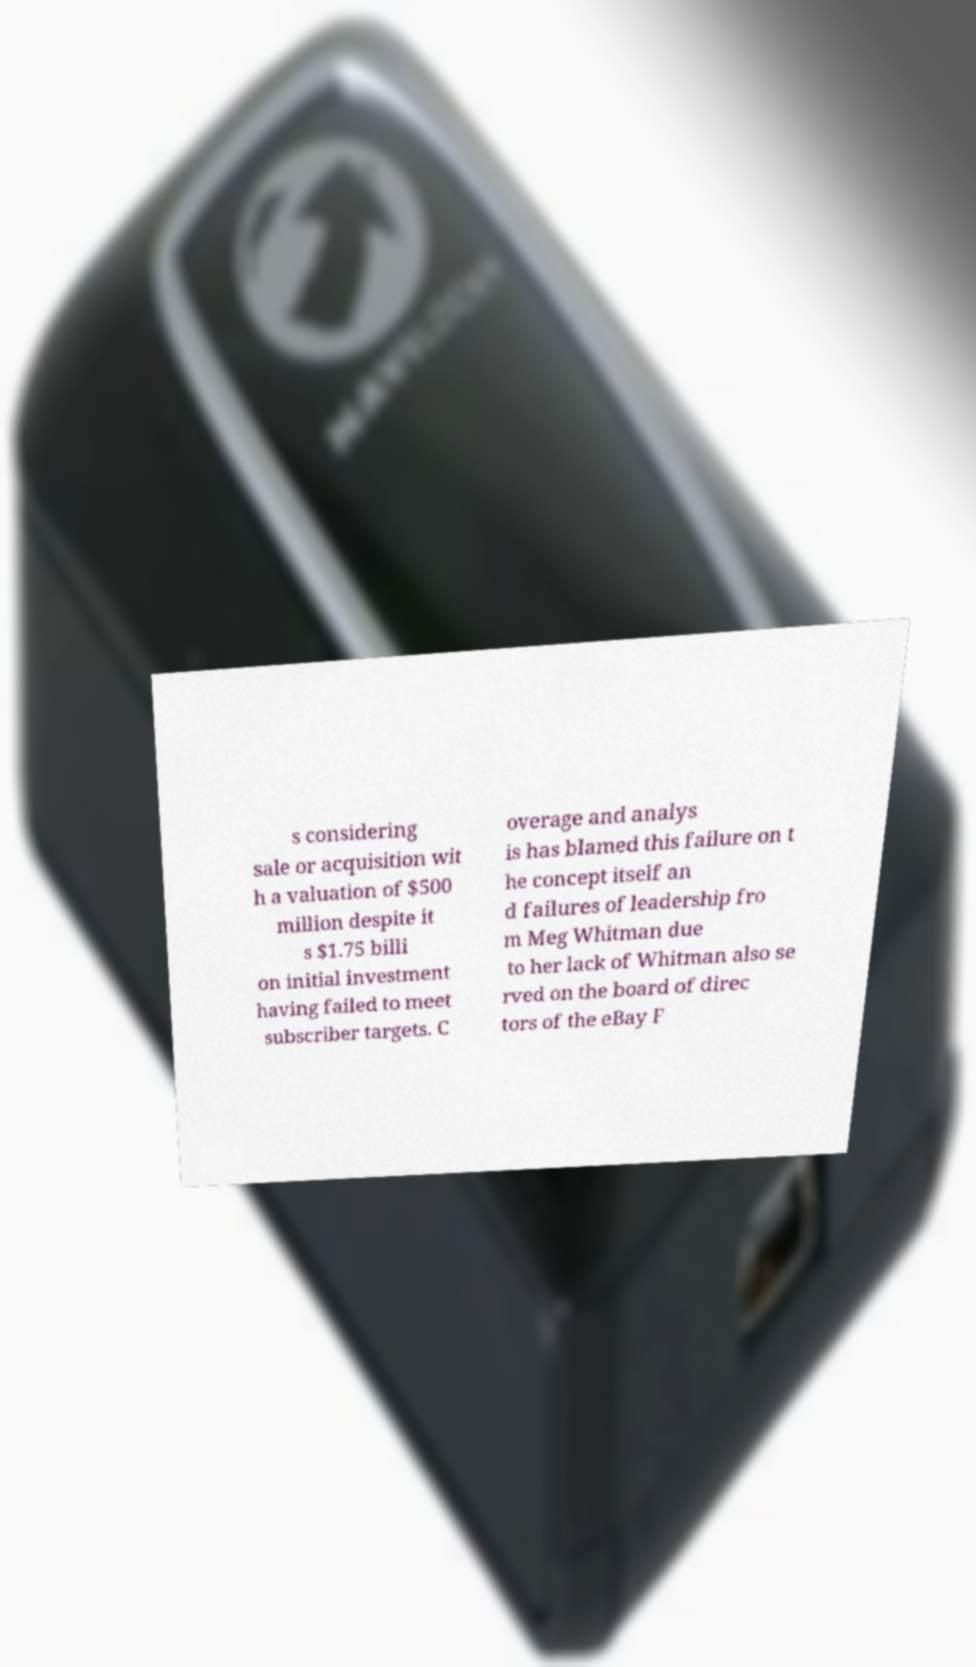There's text embedded in this image that I need extracted. Can you transcribe it verbatim? s considering sale or acquisition wit h a valuation of $500 million despite it s $1.75 billi on initial investment having failed to meet subscriber targets. C overage and analys is has blamed this failure on t he concept itself an d failures of leadership fro m Meg Whitman due to her lack of Whitman also se rved on the board of direc tors of the eBay F 